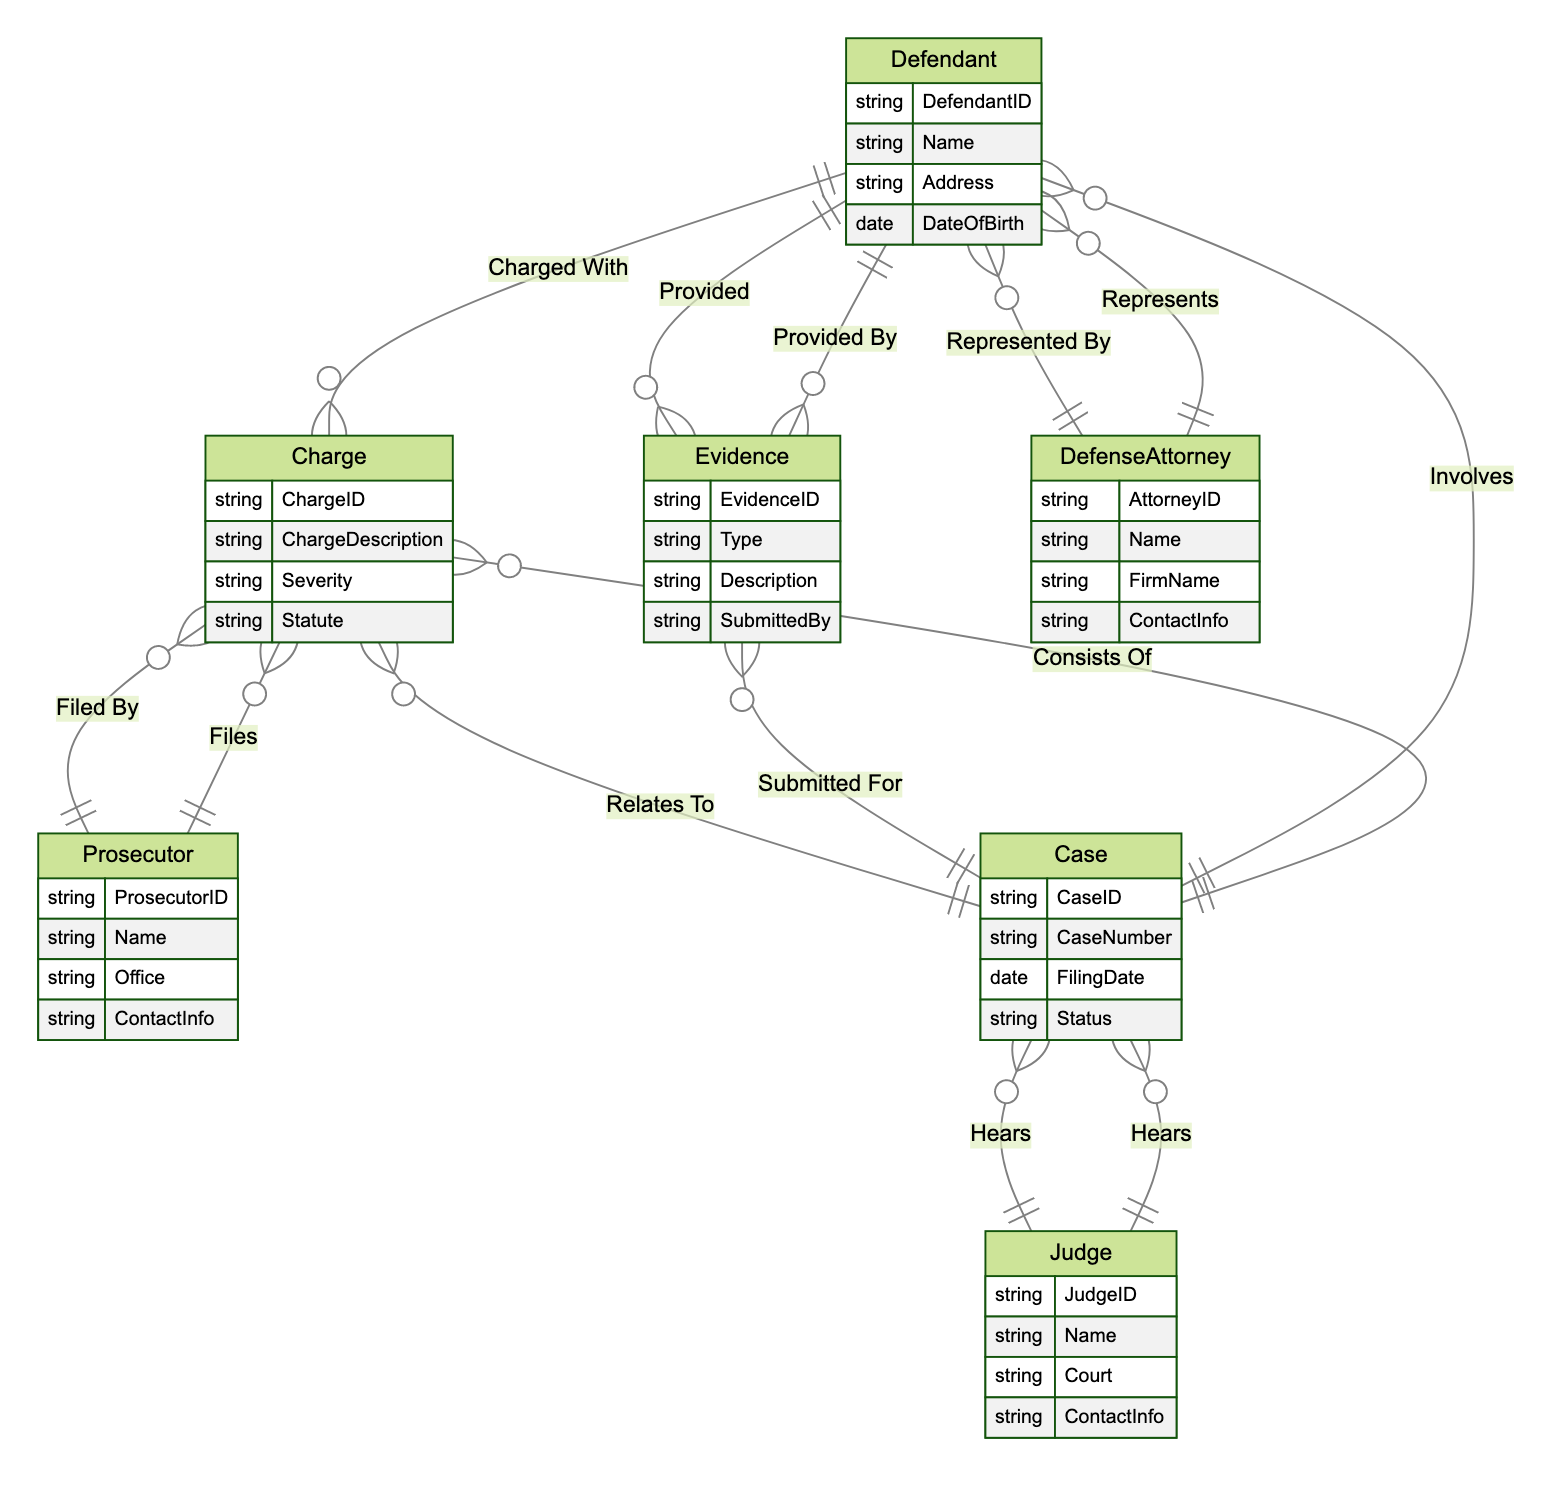What is the relationship between a Defendant and a Charge? The diagram indicates that a Defendant is "Charged With" a Charge, representing a one-to-many relationship. This means one Defendant can face multiple Charges.
Answer: Charged With How many attributes does the Case entity have? Referring to the diagram, the Case entity has four attributes: CaseID, CaseNumber, FilingDate, and Status. Therefore, counting these gives us the total.
Answer: 4 Who is responsible for filing a Charge? Based on the diagram, the prosecutor is the entity that "Files" a Charge, indicating that the relationship is many-to-one. A Charge can be filed by one Prosecutor.
Answer: Prosecutor What does the relationship between a Defendant and Evidence represent? The diagram states that a Defendant "Provided" Evidence, which means this relationship is one-to-many. A single Defendant can provide multiple types of Evidence in a case.
Answer: Provided How many entities involve a Judge? By examining the relationships involving the Judge in the diagram, we see that the Judge "Hears" multiple Cases, indicating a one-to-many relationship. The Judge is involved in multiple Case entities.
Answer: 1 Which entity is represented by the relationship "Involves"? The diagram highlights that the Case entity "Involves" the Defendant, depicting a one-to-many relationship where one Case can involve multiple Defendants.
Answer: Defendant What does "Submitted For" indicate in this diagram? In the context of the diagram, "Submitted For" signifies that Evidence is related to a Case, indicating that multiple pieces of Evidence can be submitted for a single Case.
Answer: Case Which entity has a many-to-one relationship with Evidence? According to the relationships depicted in the diagram, Evidence has a many-to-one relationship with the Case entity, as many pieces of Evidence can be linked to one Case.
Answer: Case 